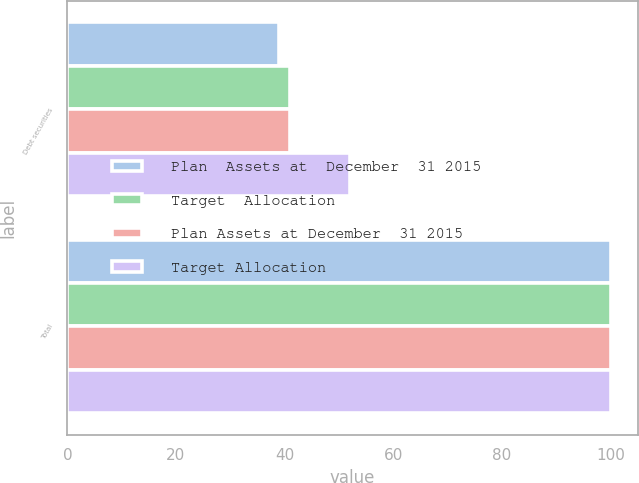Convert chart. <chart><loc_0><loc_0><loc_500><loc_500><stacked_bar_chart><ecel><fcel>Debt securities<fcel>Total<nl><fcel>Plan  Assets at  December  31 2015<fcel>39<fcel>100<nl><fcel>Target  Allocation<fcel>41<fcel>100<nl><fcel>Plan Assets at December  31 2015<fcel>41<fcel>100<nl><fcel>Target Allocation<fcel>52<fcel>100<nl></chart> 